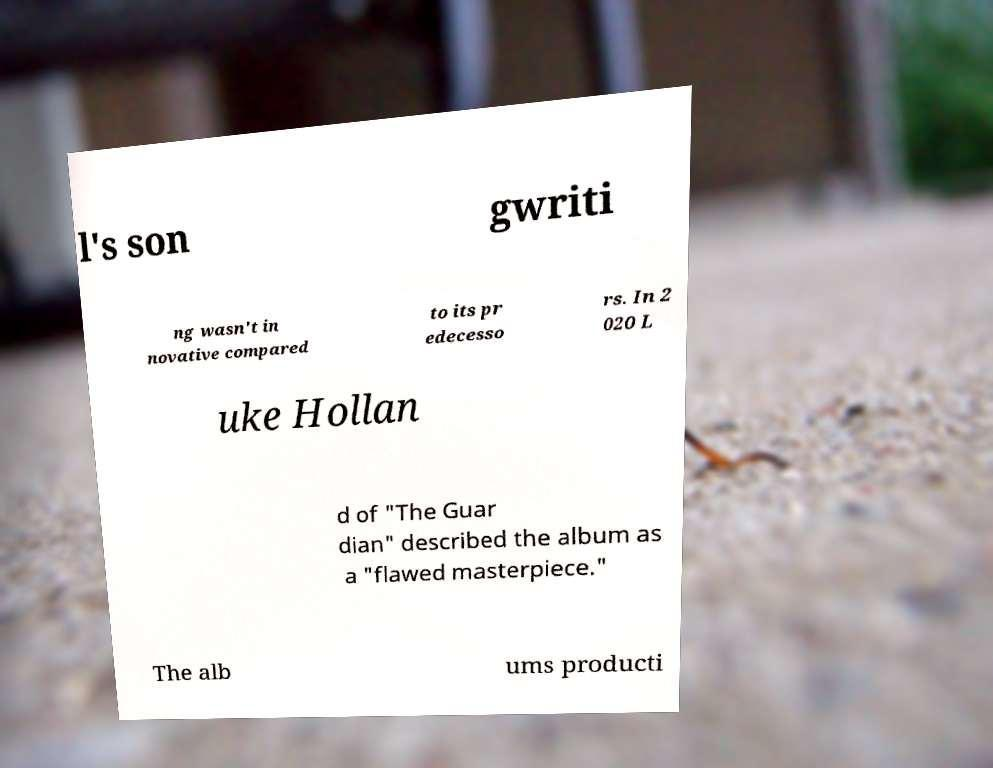For documentation purposes, I need the text within this image transcribed. Could you provide that? l's son gwriti ng wasn't in novative compared to its pr edecesso rs. In 2 020 L uke Hollan d of "The Guar dian" described the album as a "flawed masterpiece." The alb ums producti 